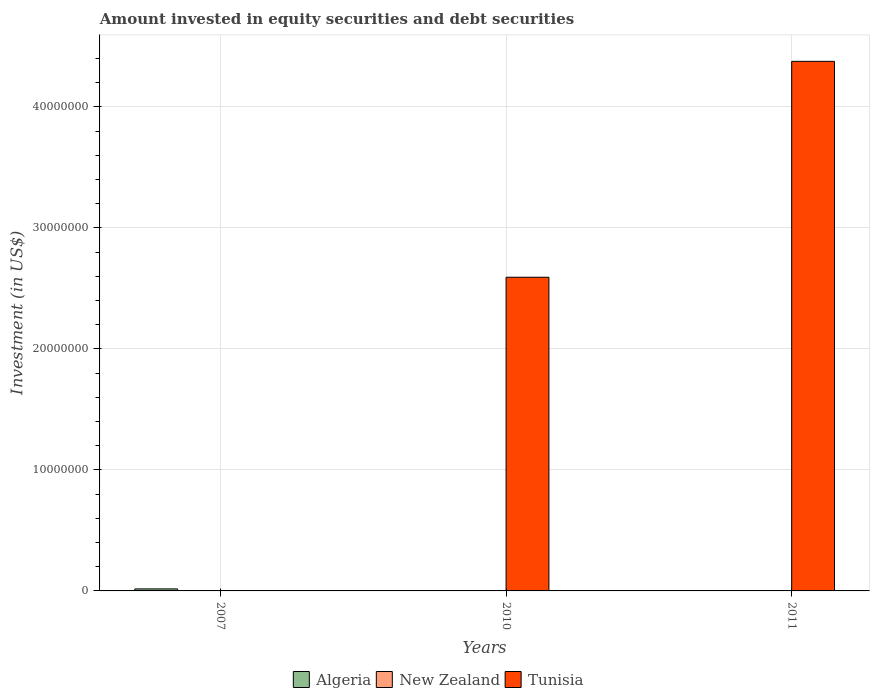Are the number of bars per tick equal to the number of legend labels?
Your answer should be compact. No. How many bars are there on the 1st tick from the left?
Provide a succinct answer. 1. How many bars are there on the 1st tick from the right?
Keep it short and to the point. 1. What is the label of the 3rd group of bars from the left?
Ensure brevity in your answer.  2011. What is the amount invested in equity securities and debt securities in Tunisia in 2010?
Provide a short and direct response. 2.59e+07. Across all years, what is the maximum amount invested in equity securities and debt securities in Algeria?
Give a very brief answer. 1.66e+05. In which year was the amount invested in equity securities and debt securities in Tunisia maximum?
Give a very brief answer. 2011. What is the total amount invested in equity securities and debt securities in Tunisia in the graph?
Make the answer very short. 6.97e+07. What is the average amount invested in equity securities and debt securities in Algeria per year?
Keep it short and to the point. 5.54e+04. In how many years, is the amount invested in equity securities and debt securities in Tunisia greater than 2000000 US$?
Give a very brief answer. 2. What is the ratio of the amount invested in equity securities and debt securities in Tunisia in 2010 to that in 2011?
Provide a succinct answer. 0.59. What is the difference between the highest and the lowest amount invested in equity securities and debt securities in Tunisia?
Offer a terse response. 4.38e+07. Are all the bars in the graph horizontal?
Offer a very short reply. No. What is the difference between two consecutive major ticks on the Y-axis?
Keep it short and to the point. 1.00e+07. Does the graph contain any zero values?
Make the answer very short. Yes. Where does the legend appear in the graph?
Keep it short and to the point. Bottom center. How many legend labels are there?
Your answer should be compact. 3. What is the title of the graph?
Your answer should be very brief. Amount invested in equity securities and debt securities. Does "Iraq" appear as one of the legend labels in the graph?
Your answer should be compact. No. What is the label or title of the Y-axis?
Give a very brief answer. Investment (in US$). What is the Investment (in US$) of Algeria in 2007?
Provide a succinct answer. 1.66e+05. What is the Investment (in US$) of Tunisia in 2007?
Provide a short and direct response. 0. What is the Investment (in US$) in Tunisia in 2010?
Give a very brief answer. 2.59e+07. What is the Investment (in US$) of Algeria in 2011?
Ensure brevity in your answer.  0. What is the Investment (in US$) of New Zealand in 2011?
Make the answer very short. 0. What is the Investment (in US$) in Tunisia in 2011?
Your response must be concise. 4.38e+07. Across all years, what is the maximum Investment (in US$) in Algeria?
Provide a short and direct response. 1.66e+05. Across all years, what is the maximum Investment (in US$) of Tunisia?
Your answer should be compact. 4.38e+07. Across all years, what is the minimum Investment (in US$) in Algeria?
Offer a very short reply. 0. Across all years, what is the minimum Investment (in US$) of Tunisia?
Offer a terse response. 0. What is the total Investment (in US$) of Algeria in the graph?
Provide a short and direct response. 1.66e+05. What is the total Investment (in US$) of New Zealand in the graph?
Keep it short and to the point. 0. What is the total Investment (in US$) in Tunisia in the graph?
Ensure brevity in your answer.  6.97e+07. What is the difference between the Investment (in US$) of Tunisia in 2010 and that in 2011?
Make the answer very short. -1.78e+07. What is the difference between the Investment (in US$) of Algeria in 2007 and the Investment (in US$) of Tunisia in 2010?
Keep it short and to the point. -2.58e+07. What is the difference between the Investment (in US$) in Algeria in 2007 and the Investment (in US$) in Tunisia in 2011?
Make the answer very short. -4.36e+07. What is the average Investment (in US$) in Algeria per year?
Keep it short and to the point. 5.54e+04. What is the average Investment (in US$) of Tunisia per year?
Provide a succinct answer. 2.32e+07. What is the ratio of the Investment (in US$) in Tunisia in 2010 to that in 2011?
Provide a succinct answer. 0.59. What is the difference between the highest and the lowest Investment (in US$) of Algeria?
Ensure brevity in your answer.  1.66e+05. What is the difference between the highest and the lowest Investment (in US$) in Tunisia?
Ensure brevity in your answer.  4.38e+07. 